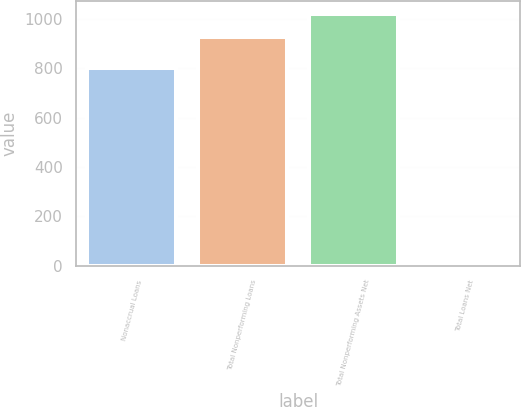Convert chart to OTSL. <chart><loc_0><loc_0><loc_500><loc_500><bar_chart><fcel>Nonaccrual Loans<fcel>Total Nonperforming Loans<fcel>Total Nonperforming Assets Net<fcel>Total Loans Net<nl><fcel>801<fcel>926<fcel>1018.59<fcel>0.13<nl></chart> 